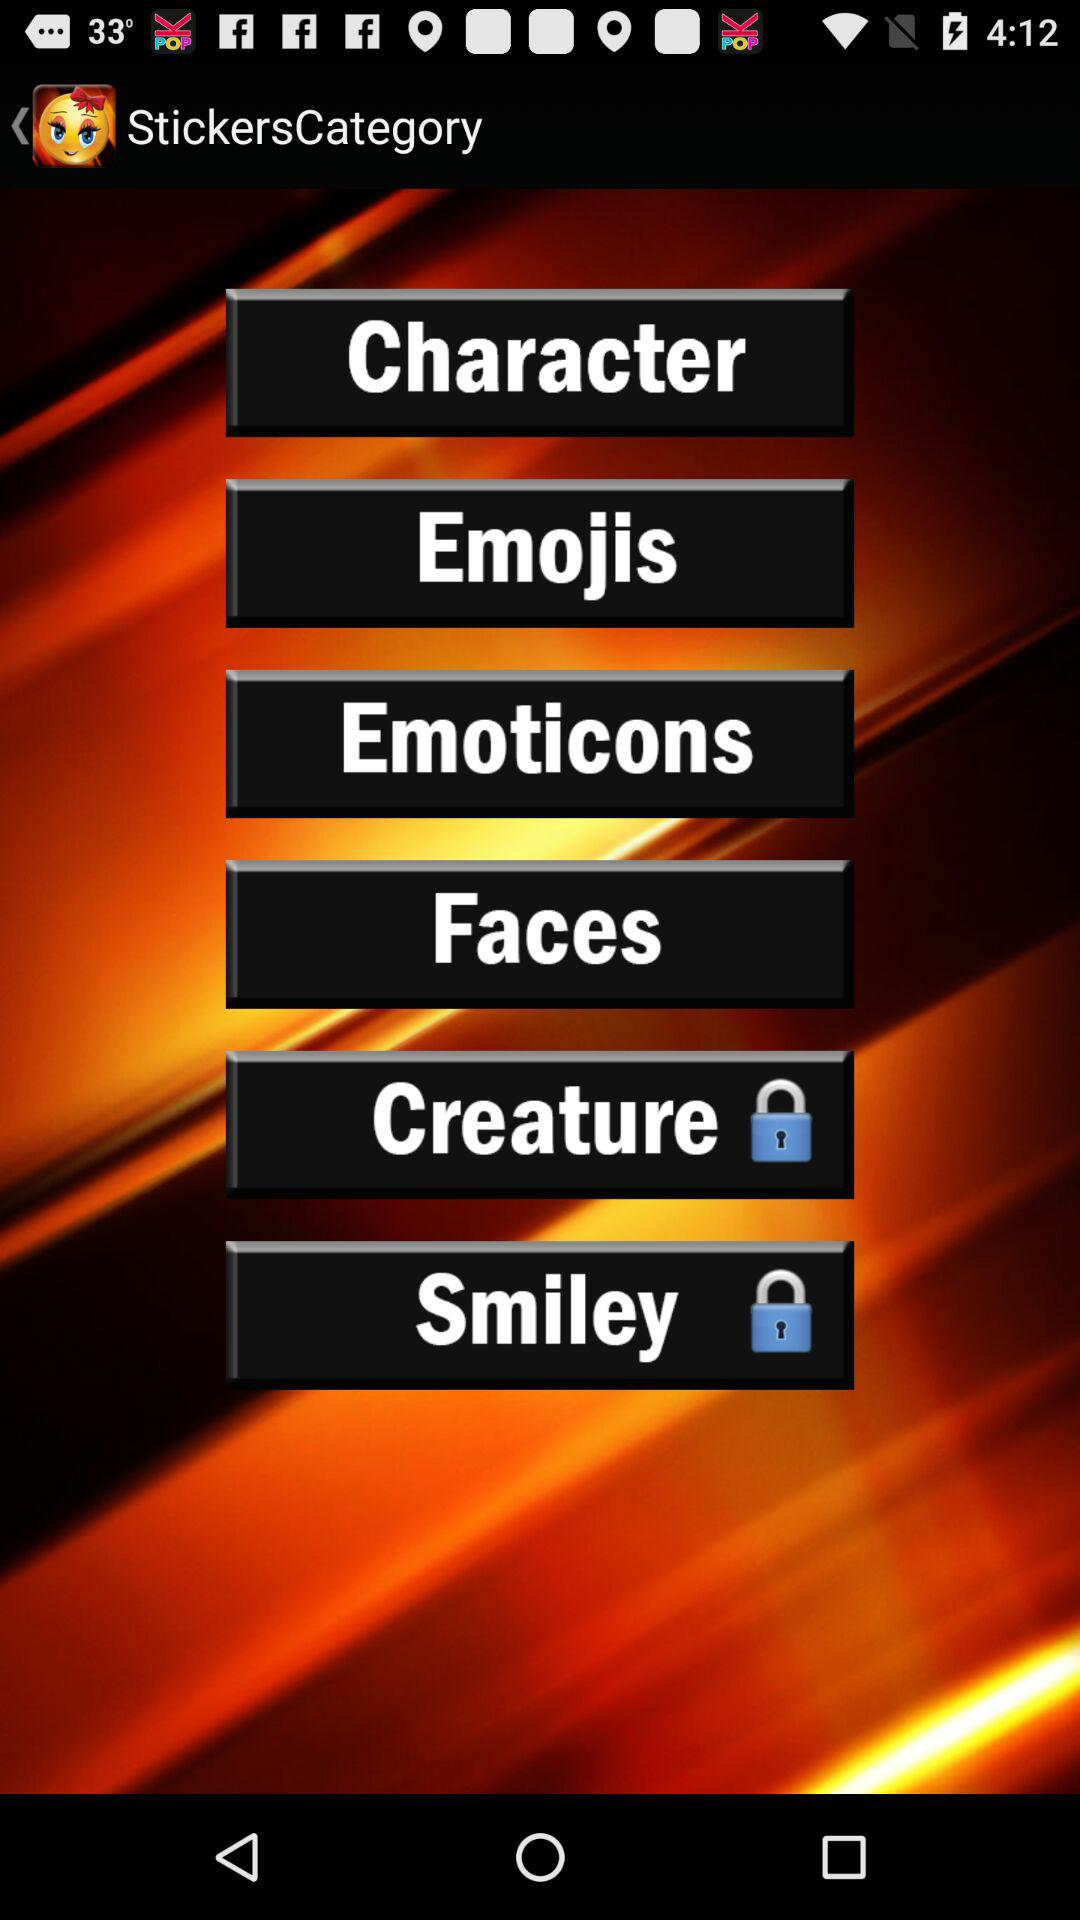Which sticker categories are locked? The sticker categories that are locked are "Creature" and "Smiley". 